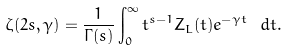Convert formula to latex. <formula><loc_0><loc_0><loc_500><loc_500>\zeta ( 2 s , \gamma ) = \frac { 1 } { \Gamma ( s ) } \int _ { 0 } ^ { \infty } t ^ { s - 1 } Z _ { L } ( t ) e ^ { - \gamma t } \ d t .</formula> 